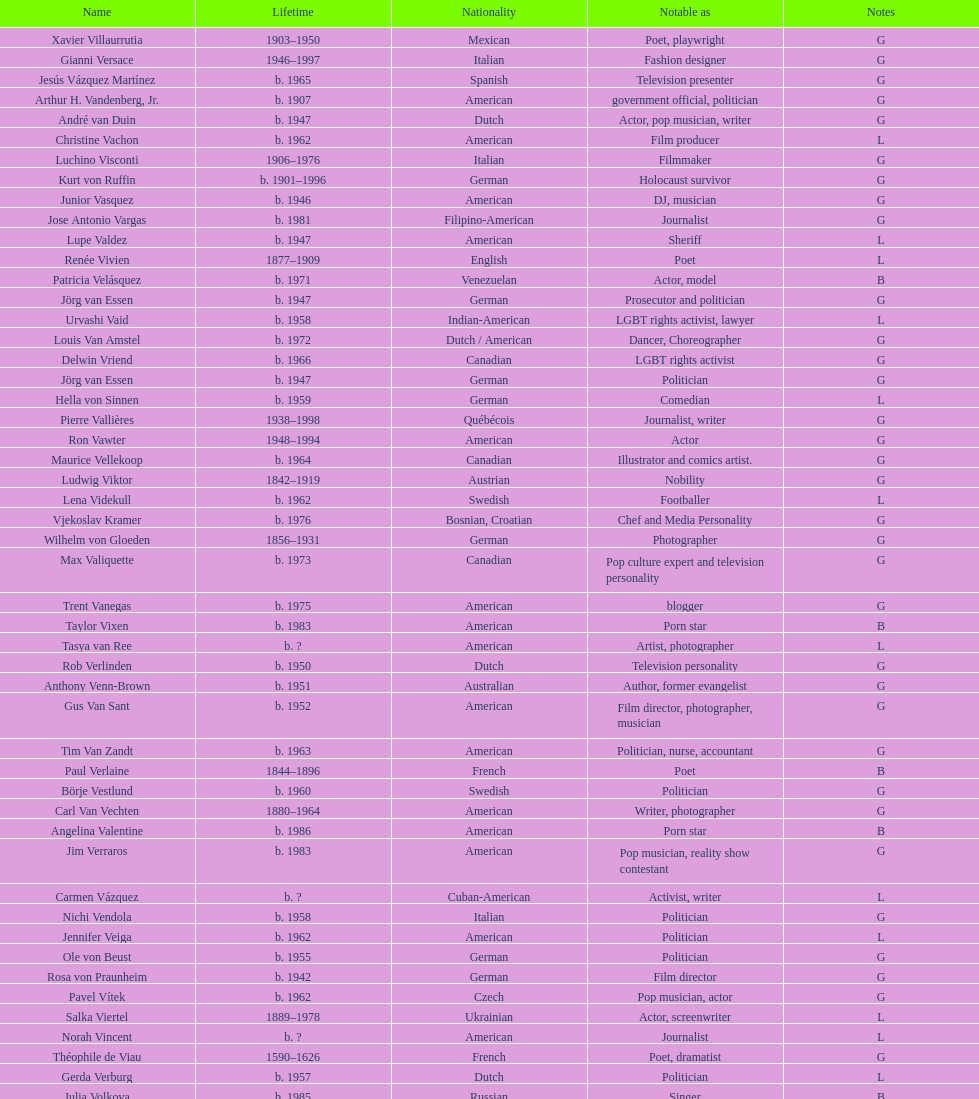Who lived longer, van vechten or variacoes? Van Vechten. Can you parse all the data within this table? {'header': ['Name', 'Lifetime', 'Nationality', 'Notable as', 'Notes'], 'rows': [['Xavier Villaurrutia', '1903–1950', 'Mexican', 'Poet, playwright', 'G'], ['Gianni Versace', '1946–1997', 'Italian', 'Fashion designer', 'G'], ['Jesús Vázquez Martínez', 'b. 1965', 'Spanish', 'Television presenter', 'G'], ['Arthur H. Vandenberg, Jr.', 'b. 1907', 'American', 'government official, politician', 'G'], ['André van Duin', 'b. 1947', 'Dutch', 'Actor, pop musician, writer', 'G'], ['Christine Vachon', 'b. 1962', 'American', 'Film producer', 'L'], ['Luchino Visconti', '1906–1976', 'Italian', 'Filmmaker', 'G'], ['Kurt von Ruffin', 'b. 1901–1996', 'German', 'Holocaust survivor', 'G'], ['Junior Vasquez', 'b. 1946', 'American', 'DJ, musician', 'G'], ['Jose Antonio Vargas', 'b. 1981', 'Filipino-American', 'Journalist', 'G'], ['Lupe Valdez', 'b. 1947', 'American', 'Sheriff', 'L'], ['Renée Vivien', '1877–1909', 'English', 'Poet', 'L'], ['Patricia Velásquez', 'b. 1971', 'Venezuelan', 'Actor, model', 'B'], ['Jörg van Essen', 'b. 1947', 'German', 'Prosecutor and politician', 'G'], ['Urvashi Vaid', 'b. 1958', 'Indian-American', 'LGBT rights activist, lawyer', 'L'], ['Louis Van Amstel', 'b. 1972', 'Dutch / American', 'Dancer, Choreographer', 'G'], ['Delwin Vriend', 'b. 1966', 'Canadian', 'LGBT rights activist', 'G'], ['Jörg van Essen', 'b. 1947', 'German', 'Politician', 'G'], ['Hella von Sinnen', 'b. 1959', 'German', 'Comedian', 'L'], ['Pierre Vallières', '1938–1998', 'Québécois', 'Journalist, writer', 'G'], ['Ron Vawter', '1948–1994', 'American', 'Actor', 'G'], ['Maurice Vellekoop', 'b. 1964', 'Canadian', 'Illustrator and comics artist.', 'G'], ['Ludwig Viktor', '1842–1919', 'Austrian', 'Nobility', 'G'], ['Lena Videkull', 'b. 1962', 'Swedish', 'Footballer', 'L'], ['Vjekoslav Kramer', 'b. 1976', 'Bosnian, Croatian', 'Chef and Media Personality', 'G'], ['Wilhelm von Gloeden', '1856–1931', 'German', 'Photographer', 'G'], ['Max Valiquette', 'b. 1973', 'Canadian', 'Pop culture expert and television personality', 'G'], ['Trent Vanegas', 'b. 1975', 'American', 'blogger', 'G'], ['Taylor Vixen', 'b. 1983', 'American', 'Porn star', 'B'], ['Tasya van Ree', 'b.\xa0?', 'American', 'Artist, photographer', 'L'], ['Rob Verlinden', 'b. 1950', 'Dutch', 'Television personality', 'G'], ['Anthony Venn-Brown', 'b. 1951', 'Australian', 'Author, former evangelist', 'G'], ['Gus Van Sant', 'b. 1952', 'American', 'Film director, photographer, musician', 'G'], ['Tim Van Zandt', 'b. 1963', 'American', 'Politician, nurse, accountant', 'G'], ['Paul Verlaine', '1844–1896', 'French', 'Poet', 'B'], ['Börje Vestlund', 'b. 1960', 'Swedish', 'Politician', 'G'], ['Carl Van Vechten', '1880–1964', 'American', 'Writer, photographer', 'G'], ['Angelina Valentine', 'b. 1986', 'American', 'Porn star', 'B'], ['Jim Verraros', 'b. 1983', 'American', 'Pop musician, reality show contestant', 'G'], ['Carmen Vázquez', 'b.\xa0?', 'Cuban-American', 'Activist, writer', 'L'], ['Nichi Vendola', 'b. 1958', 'Italian', 'Politician', 'G'], ['Jennifer Veiga', 'b. 1962', 'American', 'Politician', 'L'], ['Ole von Beust', 'b. 1955', 'German', 'Politician', 'G'], ['Rosa von Praunheim', 'b. 1942', 'German', 'Film director', 'G'], ['Pavel Vítek', 'b. 1962', 'Czech', 'Pop musician, actor', 'G'], ['Salka Viertel', '1889–1978', 'Ukrainian', 'Actor, screenwriter', 'L'], ['Norah Vincent', 'b.\xa0?', 'American', 'Journalist', 'L'], ['Théophile de Viau', '1590–1626', 'French', 'Poet, dramatist', 'G'], ['Gerda Verburg', 'b. 1957', 'Dutch', 'Politician', 'L'], ['Julia Volkova', 'b. 1985', 'Russian', 'Singer', 'B'], ['Reg Vermue', 'b.\xa0?', 'Canadian', 'Rock musician', 'G'], ['Paco Vidarte', '1970–2008', 'Spanish', 'Writer, LGBT rights activist', 'G'], ['Ruth Vanita', 'b. 1955', 'Indian', 'Academic, activist', 'L'], ['Chavela Vargas', 'b. 1919', 'Mexican', 'Latin musician', 'L'], ['Gianni Vattimo', 'b. 1936', 'Italian', 'Writer, philosopher', 'G'], ['John Vassall', '1924–1996', 'English', 'Civil servant, spy', 'G'], ['R. M. Vaughan', 'b.\xa0?', 'Canadian', 'Poet, writer', 'G'], ['Keith Vaughan', '1912–1977', 'English', 'Painter', 'G'], ['António Variações', '1944–1984', 'Portuguese', 'Pop musician', 'G'], ['Paula Vogel', 'b. 1951', 'American', 'Playwright', 'L'], ["Alain-Philippe Malagnac d'Argens de Villèle", '1950–2000', 'French', 'Aristocrat', 'G'], ['Mário Cesariny de Vasconcelos', '1923–2006', 'Portuguese', 'Poet', 'G'], ['Bruce Voeller', '1934–1994', 'American', 'HIV/AIDS researcher', 'G'], ['Bruce Vilanch', 'b. 1948', 'American', 'Comedy writer, actor', 'G'], ['Gore Vidal', '1925–2012', 'American', 'Writer, actor', 'B'], ['Donald Vining', '1917–1998', 'American', 'Writer', 'G'], ['Tom Villard', '1953–1994', 'American', 'Actor', 'G'], ['Werner Veigel', '1928–1995', 'German', 'News presenter', 'G'], ['Claude Vivier', '1948–1983', 'Canadian', '20th century classical composer', 'G'], ['Daniel Vosovic', 'b. 1981', 'American', 'Fashion designer', 'G'], ['Elihu Vedder', '1836–1923', 'American', 'Painter, illustrator', 'G'], ['Nick Verreos', 'b. 1967', 'American', 'Fashion designer', 'G'], ['José Villarrubia', 'b. 1961', 'American', 'Artist', 'G']]} 